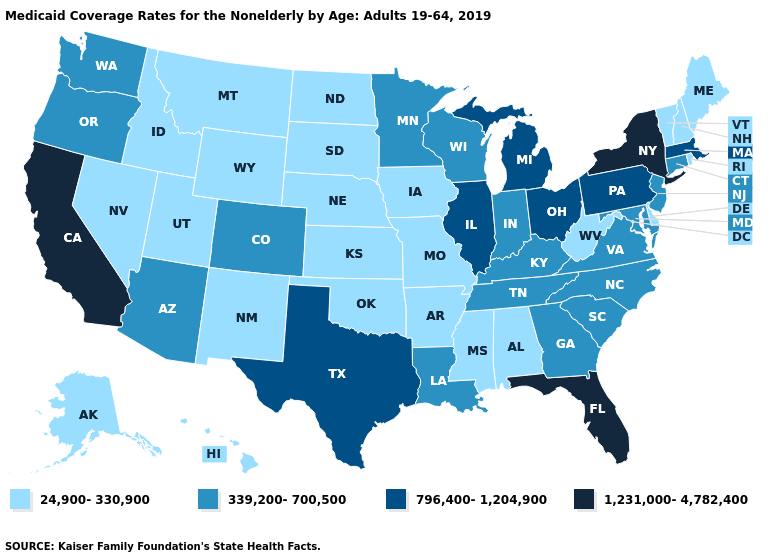Does Florida have the highest value in the USA?
Keep it brief. Yes. Does Pennsylvania have the highest value in the Northeast?
Concise answer only. No. Name the states that have a value in the range 339,200-700,500?
Write a very short answer. Arizona, Colorado, Connecticut, Georgia, Indiana, Kentucky, Louisiana, Maryland, Minnesota, New Jersey, North Carolina, Oregon, South Carolina, Tennessee, Virginia, Washington, Wisconsin. Name the states that have a value in the range 339,200-700,500?
Concise answer only. Arizona, Colorado, Connecticut, Georgia, Indiana, Kentucky, Louisiana, Maryland, Minnesota, New Jersey, North Carolina, Oregon, South Carolina, Tennessee, Virginia, Washington, Wisconsin. What is the value of Washington?
Short answer required. 339,200-700,500. Name the states that have a value in the range 1,231,000-4,782,400?
Answer briefly. California, Florida, New York. Which states hav the highest value in the South?
Concise answer only. Florida. What is the lowest value in states that border New Mexico?
Keep it brief. 24,900-330,900. Name the states that have a value in the range 1,231,000-4,782,400?
Answer briefly. California, Florida, New York. What is the lowest value in the West?
Short answer required. 24,900-330,900. Which states have the lowest value in the USA?
Short answer required. Alabama, Alaska, Arkansas, Delaware, Hawaii, Idaho, Iowa, Kansas, Maine, Mississippi, Missouri, Montana, Nebraska, Nevada, New Hampshire, New Mexico, North Dakota, Oklahoma, Rhode Island, South Dakota, Utah, Vermont, West Virginia, Wyoming. Name the states that have a value in the range 24,900-330,900?
Keep it brief. Alabama, Alaska, Arkansas, Delaware, Hawaii, Idaho, Iowa, Kansas, Maine, Mississippi, Missouri, Montana, Nebraska, Nevada, New Hampshire, New Mexico, North Dakota, Oklahoma, Rhode Island, South Dakota, Utah, Vermont, West Virginia, Wyoming. Does Florida have the highest value in the South?
Short answer required. Yes. What is the value of North Dakota?
Give a very brief answer. 24,900-330,900. 